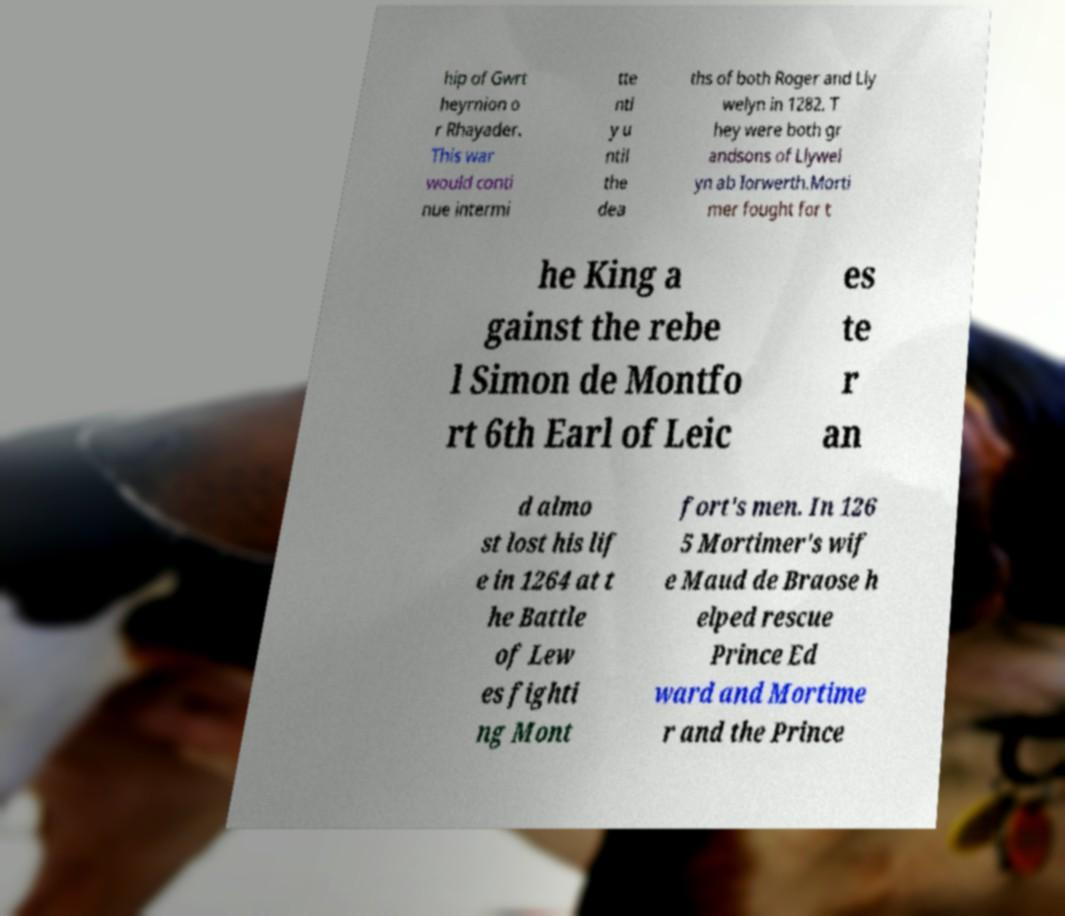Please identify and transcribe the text found in this image. hip of Gwrt heyrnion o r Rhayader. This war would conti nue intermi tte ntl y u ntil the dea ths of both Roger and Lly welyn in 1282. T hey were both gr andsons of Llywel yn ab Iorwerth.Morti mer fought for t he King a gainst the rebe l Simon de Montfo rt 6th Earl of Leic es te r an d almo st lost his lif e in 1264 at t he Battle of Lew es fighti ng Mont fort's men. In 126 5 Mortimer's wif e Maud de Braose h elped rescue Prince Ed ward and Mortime r and the Prince 